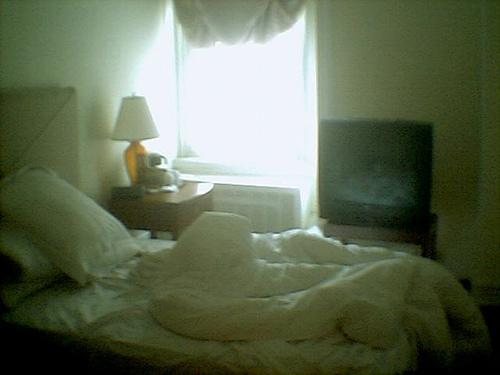What color is the bed?
Keep it brief. White. What shape is the bed?
Keep it brief. Rectangle. Is the bed made in this picture?
Quick response, please. No. Is the bed made?
Be succinct. No. Is anybody in the bed?
Short answer required. No. What color is the bed's sheets?
Write a very short answer. White. 